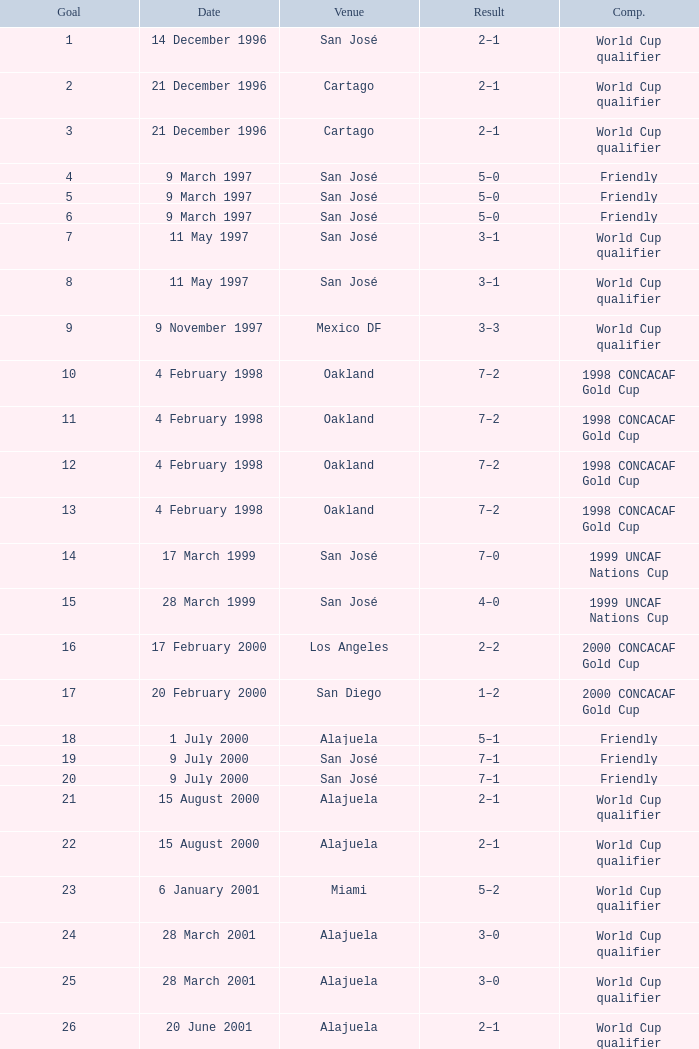What is the result in oakland? 7–2, 7–2, 7–2, 7–2. 